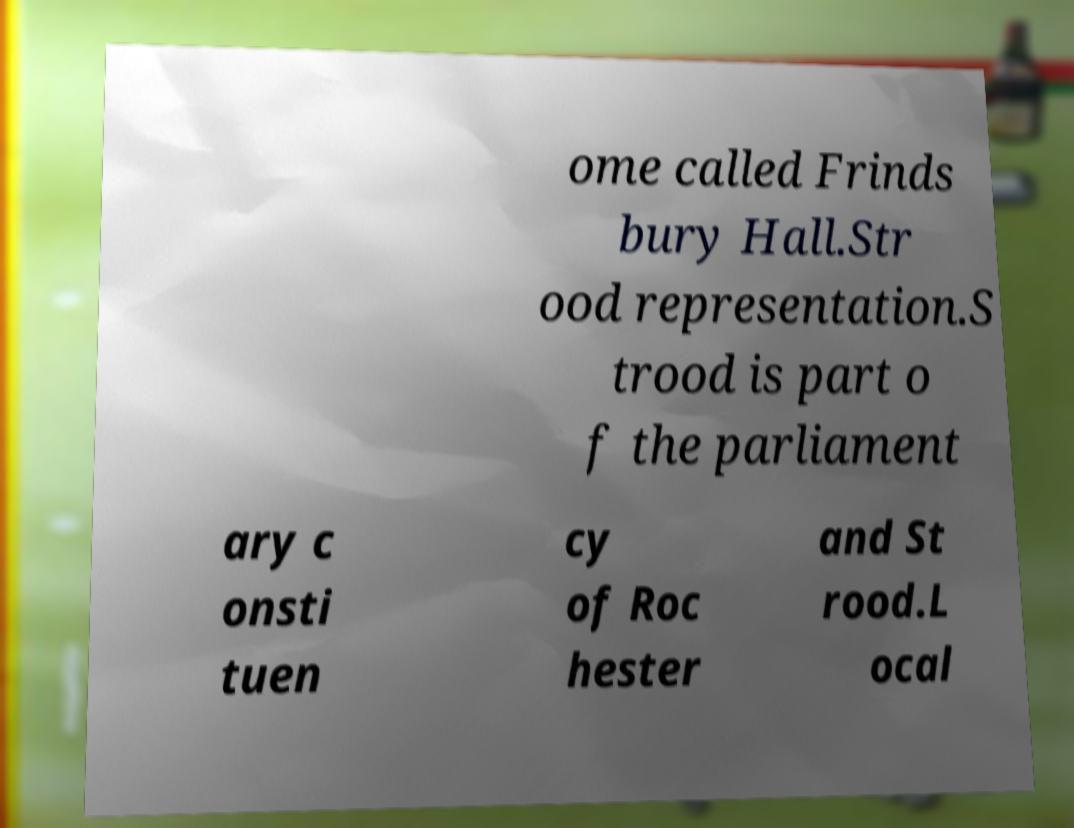Could you assist in decoding the text presented in this image and type it out clearly? ome called Frinds bury Hall.Str ood representation.S trood is part o f the parliament ary c onsti tuen cy of Roc hester and St rood.L ocal 